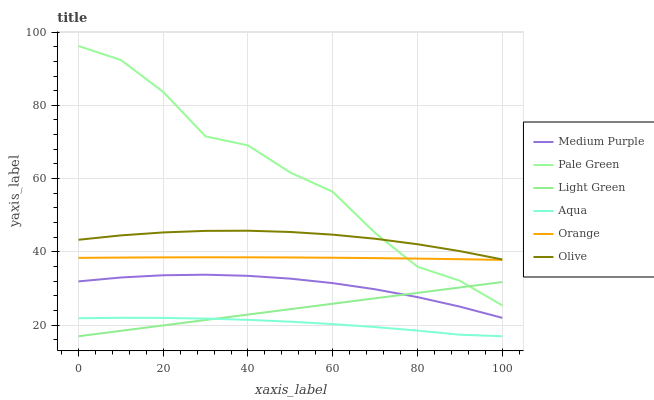Does Aqua have the minimum area under the curve?
Answer yes or no. Yes. Does Pale Green have the maximum area under the curve?
Answer yes or no. Yes. Does Medium Purple have the minimum area under the curve?
Answer yes or no. No. Does Medium Purple have the maximum area under the curve?
Answer yes or no. No. Is Light Green the smoothest?
Answer yes or no. Yes. Is Pale Green the roughest?
Answer yes or no. Yes. Is Medium Purple the smoothest?
Answer yes or no. No. Is Medium Purple the roughest?
Answer yes or no. No. Does Medium Purple have the lowest value?
Answer yes or no. No. Does Pale Green have the highest value?
Answer yes or no. Yes. Does Medium Purple have the highest value?
Answer yes or no. No. Is Aqua less than Medium Purple?
Answer yes or no. Yes. Is Orange greater than Aqua?
Answer yes or no. Yes. Does Aqua intersect Medium Purple?
Answer yes or no. No. 